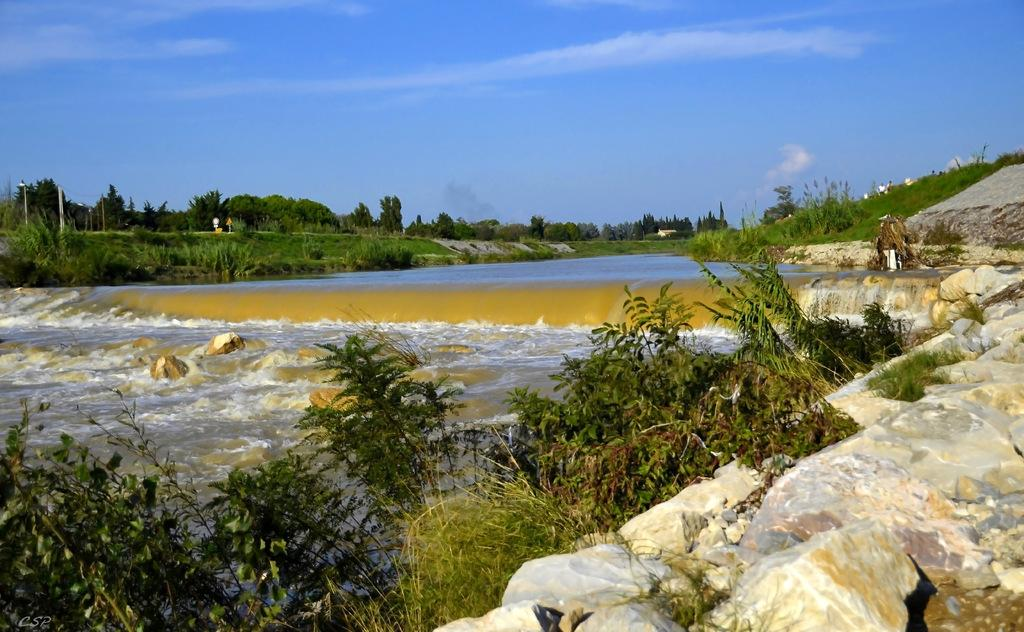What type of natural elements can be seen in the image? There are rocks, plants, water, and trees visible in the image. What man-made structures are present in the image? There are poles in the image. What part of the natural environment is visible in the image? The sky is visible in the image. Can you tell me how many goats are grazing near the trees in the image? There are no goats present in the image; it only features rocks, plants, water, trees, poles, and the sky. What type of locket is hanging from the tree in the image? There is no locket present in the image; it only features rocks, plants, water, trees, poles, and the sky. 